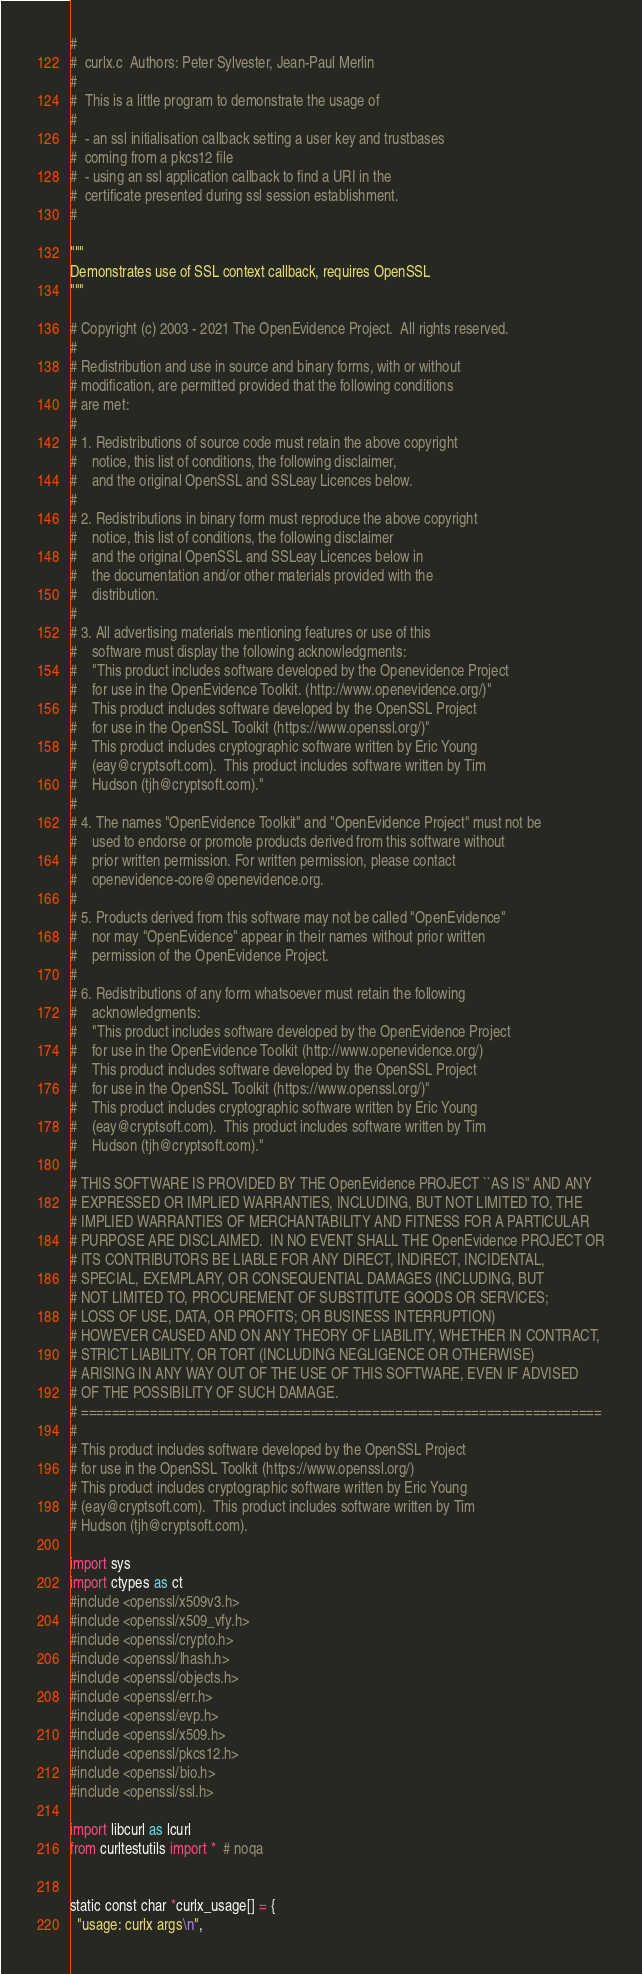<code> <loc_0><loc_0><loc_500><loc_500><_Python_>#
#  curlx.c  Authors: Peter Sylvester, Jean-Paul Merlin
#
#  This is a little program to demonstrate the usage of
#
#  - an ssl initialisation callback setting a user key and trustbases
#  coming from a pkcs12 file
#  - using an ssl application callback to find a URI in the
#  certificate presented during ssl session establishment.
#

"""
Demonstrates use of SSL context callback, requires OpenSSL
"""

# Copyright (c) 2003 - 2021 The OpenEvidence Project.  All rights reserved.
#
# Redistribution and use in source and binary forms, with or without
# modification, are permitted provided that the following conditions
# are met:
#
# 1. Redistributions of source code must retain the above copyright
#    notice, this list of conditions, the following disclaimer,
#    and the original OpenSSL and SSLeay Licences below.
#
# 2. Redistributions in binary form must reproduce the above copyright
#    notice, this list of conditions, the following disclaimer
#    and the original OpenSSL and SSLeay Licences below in
#    the documentation and/or other materials provided with the
#    distribution.
#
# 3. All advertising materials mentioning features or use of this
#    software must display the following acknowledgments:
#    "This product includes software developed by the Openevidence Project
#    for use in the OpenEvidence Toolkit. (http://www.openevidence.org/)"
#    This product includes software developed by the OpenSSL Project
#    for use in the OpenSSL Toolkit (https://www.openssl.org/)"
#    This product includes cryptographic software written by Eric Young
#    (eay@cryptsoft.com).  This product includes software written by Tim
#    Hudson (tjh@cryptsoft.com)."
#
# 4. The names "OpenEvidence Toolkit" and "OpenEvidence Project" must not be
#    used to endorse or promote products derived from this software without
#    prior written permission. For written permission, please contact
#    openevidence-core@openevidence.org.
#
# 5. Products derived from this software may not be called "OpenEvidence"
#    nor may "OpenEvidence" appear in their names without prior written
#    permission of the OpenEvidence Project.
#
# 6. Redistributions of any form whatsoever must retain the following
#    acknowledgments:
#    "This product includes software developed by the OpenEvidence Project
#    for use in the OpenEvidence Toolkit (http://www.openevidence.org/)
#    This product includes software developed by the OpenSSL Project
#    for use in the OpenSSL Toolkit (https://www.openssl.org/)"
#    This product includes cryptographic software written by Eric Young
#    (eay@cryptsoft.com).  This product includes software written by Tim
#    Hudson (tjh@cryptsoft.com)."
#
# THIS SOFTWARE IS PROVIDED BY THE OpenEvidence PROJECT ``AS IS'' AND ANY
# EXPRESSED OR IMPLIED WARRANTIES, INCLUDING, BUT NOT LIMITED TO, THE
# IMPLIED WARRANTIES OF MERCHANTABILITY AND FITNESS FOR A PARTICULAR
# PURPOSE ARE DISCLAIMED.  IN NO EVENT SHALL THE OpenEvidence PROJECT OR
# ITS CONTRIBUTORS BE LIABLE FOR ANY DIRECT, INDIRECT, INCIDENTAL,
# SPECIAL, EXEMPLARY, OR CONSEQUENTIAL DAMAGES (INCLUDING, BUT
# NOT LIMITED TO, PROCUREMENT OF SUBSTITUTE GOODS OR SERVICES;
# LOSS OF USE, DATA, OR PROFITS; OR BUSINESS INTERRUPTION)
# HOWEVER CAUSED AND ON ANY THEORY OF LIABILITY, WHETHER IN CONTRACT,
# STRICT LIABILITY, OR TORT (INCLUDING NEGLIGENCE OR OTHERWISE)
# ARISING IN ANY WAY OUT OF THE USE OF THIS SOFTWARE, EVEN IF ADVISED
# OF THE POSSIBILITY OF SUCH DAMAGE.
# ====================================================================
#
# This product includes software developed by the OpenSSL Project
# for use in the OpenSSL Toolkit (https://www.openssl.org/)
# This product includes cryptographic software written by Eric Young
# (eay@cryptsoft.com).  This product includes software written by Tim
# Hudson (tjh@cryptsoft.com).

import sys
import ctypes as ct
#include <openssl/x509v3.h>
#include <openssl/x509_vfy.h>
#include <openssl/crypto.h>
#include <openssl/lhash.h>
#include <openssl/objects.h>
#include <openssl/err.h>
#include <openssl/evp.h>
#include <openssl/x509.h>
#include <openssl/pkcs12.h>
#include <openssl/bio.h>
#include <openssl/ssl.h>

import libcurl as lcurl
from curltestutils import *  # noqa


static const char *curlx_usage[] = {
  "usage: curlx args\n",</code> 